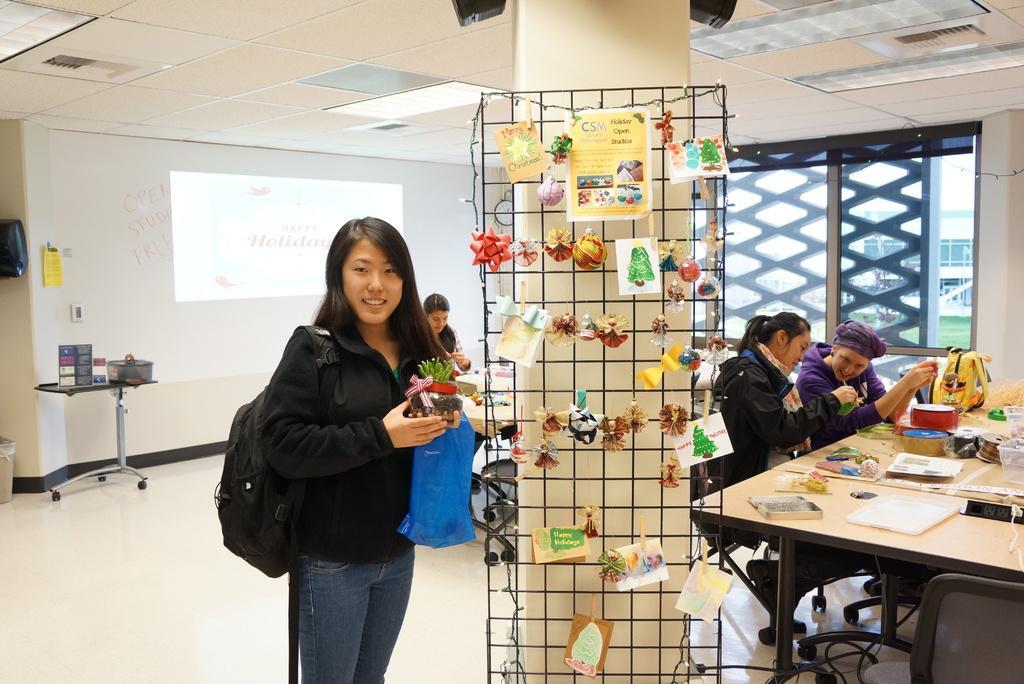Please provide a concise description of this image. In the middle left, a woman is standing and wearing a bag which is black in color and holding a houseplant in her hand. In the right middle, two person are sitting on the chair in front of the table on which papers, boxes and son kept. The background wall is white in color on which screen is there. A roof top is light yellow in color on which light is mounted. In the middle there is a net on which handicraft are hanged. This image is taken inside a room. 